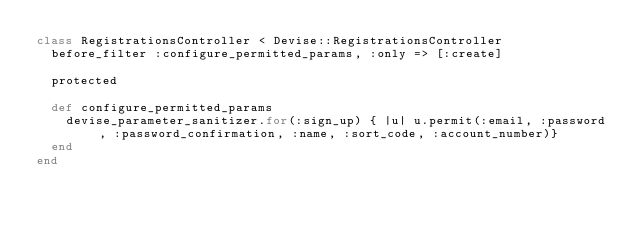<code> <loc_0><loc_0><loc_500><loc_500><_Ruby_>class RegistrationsController < Devise::RegistrationsController
  before_filter :configure_permitted_params, :only => [:create]

  protected

  def configure_permitted_params
    devise_parameter_sanitizer.for(:sign_up) { |u| u.permit(:email, :password, :password_confirmation, :name, :sort_code, :account_number)}
  end
end
</code> 